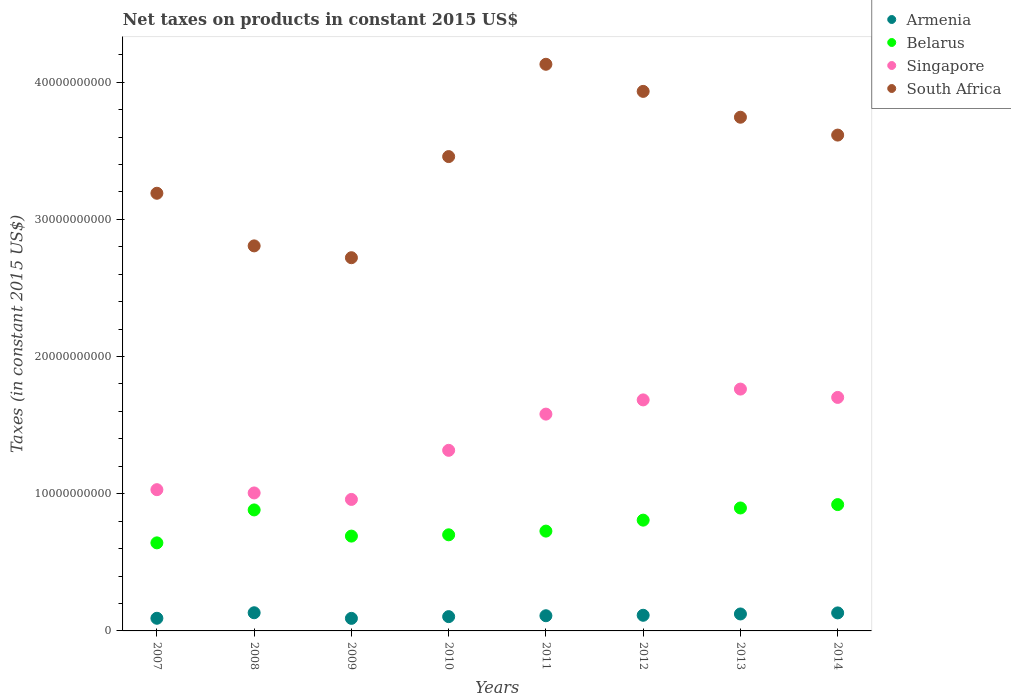How many different coloured dotlines are there?
Your response must be concise. 4. What is the net taxes on products in Belarus in 2011?
Your answer should be compact. 7.28e+09. Across all years, what is the maximum net taxes on products in Belarus?
Your answer should be compact. 9.21e+09. Across all years, what is the minimum net taxes on products in Belarus?
Offer a terse response. 6.42e+09. In which year was the net taxes on products in Armenia maximum?
Make the answer very short. 2008. In which year was the net taxes on products in South Africa minimum?
Your response must be concise. 2009. What is the total net taxes on products in Singapore in the graph?
Offer a very short reply. 1.10e+11. What is the difference between the net taxes on products in Armenia in 2008 and that in 2010?
Offer a very short reply. 2.83e+08. What is the difference between the net taxes on products in Belarus in 2011 and the net taxes on products in Armenia in 2007?
Your answer should be very brief. 6.35e+09. What is the average net taxes on products in Armenia per year?
Provide a succinct answer. 1.13e+09. In the year 2013, what is the difference between the net taxes on products in Belarus and net taxes on products in Armenia?
Provide a succinct answer. 7.73e+09. In how many years, is the net taxes on products in Belarus greater than 30000000000 US$?
Keep it short and to the point. 0. What is the ratio of the net taxes on products in Singapore in 2009 to that in 2011?
Your answer should be very brief. 0.61. Is the net taxes on products in Belarus in 2007 less than that in 2009?
Provide a succinct answer. Yes. Is the difference between the net taxes on products in Belarus in 2010 and 2012 greater than the difference between the net taxes on products in Armenia in 2010 and 2012?
Your answer should be very brief. No. What is the difference between the highest and the second highest net taxes on products in Armenia?
Your response must be concise. 1.13e+07. What is the difference between the highest and the lowest net taxes on products in Belarus?
Provide a succinct answer. 2.79e+09. In how many years, is the net taxes on products in Armenia greater than the average net taxes on products in Armenia taken over all years?
Provide a succinct answer. 4. Is it the case that in every year, the sum of the net taxes on products in South Africa and net taxes on products in Armenia  is greater than the sum of net taxes on products in Belarus and net taxes on products in Singapore?
Make the answer very short. Yes. Is it the case that in every year, the sum of the net taxes on products in Belarus and net taxes on products in Singapore  is greater than the net taxes on products in Armenia?
Your answer should be compact. Yes. Where does the legend appear in the graph?
Keep it short and to the point. Top right. How many legend labels are there?
Offer a very short reply. 4. How are the legend labels stacked?
Provide a succinct answer. Vertical. What is the title of the graph?
Provide a short and direct response. Net taxes on products in constant 2015 US$. What is the label or title of the X-axis?
Offer a terse response. Years. What is the label or title of the Y-axis?
Provide a succinct answer. Taxes (in constant 2015 US$). What is the Taxes (in constant 2015 US$) in Armenia in 2007?
Your answer should be very brief. 9.22e+08. What is the Taxes (in constant 2015 US$) of Belarus in 2007?
Your answer should be compact. 6.42e+09. What is the Taxes (in constant 2015 US$) in Singapore in 2007?
Provide a short and direct response. 1.03e+1. What is the Taxes (in constant 2015 US$) in South Africa in 2007?
Keep it short and to the point. 3.19e+1. What is the Taxes (in constant 2015 US$) in Armenia in 2008?
Ensure brevity in your answer.  1.32e+09. What is the Taxes (in constant 2015 US$) of Belarus in 2008?
Make the answer very short. 8.82e+09. What is the Taxes (in constant 2015 US$) in Singapore in 2008?
Your answer should be compact. 1.01e+1. What is the Taxes (in constant 2015 US$) in South Africa in 2008?
Your answer should be very brief. 2.81e+1. What is the Taxes (in constant 2015 US$) in Armenia in 2009?
Your response must be concise. 9.15e+08. What is the Taxes (in constant 2015 US$) in Belarus in 2009?
Make the answer very short. 6.91e+09. What is the Taxes (in constant 2015 US$) in Singapore in 2009?
Provide a succinct answer. 9.59e+09. What is the Taxes (in constant 2015 US$) of South Africa in 2009?
Your answer should be very brief. 2.72e+1. What is the Taxes (in constant 2015 US$) in Armenia in 2010?
Give a very brief answer. 1.04e+09. What is the Taxes (in constant 2015 US$) in Belarus in 2010?
Keep it short and to the point. 7.01e+09. What is the Taxes (in constant 2015 US$) of Singapore in 2010?
Provide a short and direct response. 1.32e+1. What is the Taxes (in constant 2015 US$) in South Africa in 2010?
Provide a succinct answer. 3.46e+1. What is the Taxes (in constant 2015 US$) in Armenia in 2011?
Provide a succinct answer. 1.11e+09. What is the Taxes (in constant 2015 US$) in Belarus in 2011?
Your response must be concise. 7.28e+09. What is the Taxes (in constant 2015 US$) in Singapore in 2011?
Give a very brief answer. 1.58e+1. What is the Taxes (in constant 2015 US$) of South Africa in 2011?
Provide a succinct answer. 4.13e+1. What is the Taxes (in constant 2015 US$) of Armenia in 2012?
Offer a very short reply. 1.14e+09. What is the Taxes (in constant 2015 US$) in Belarus in 2012?
Offer a terse response. 8.08e+09. What is the Taxes (in constant 2015 US$) of Singapore in 2012?
Make the answer very short. 1.68e+1. What is the Taxes (in constant 2015 US$) of South Africa in 2012?
Provide a succinct answer. 3.93e+1. What is the Taxes (in constant 2015 US$) in Armenia in 2013?
Ensure brevity in your answer.  1.24e+09. What is the Taxes (in constant 2015 US$) in Belarus in 2013?
Your answer should be very brief. 8.96e+09. What is the Taxes (in constant 2015 US$) of Singapore in 2013?
Your response must be concise. 1.76e+1. What is the Taxes (in constant 2015 US$) of South Africa in 2013?
Your response must be concise. 3.74e+1. What is the Taxes (in constant 2015 US$) in Armenia in 2014?
Offer a very short reply. 1.31e+09. What is the Taxes (in constant 2015 US$) in Belarus in 2014?
Offer a terse response. 9.21e+09. What is the Taxes (in constant 2015 US$) of Singapore in 2014?
Provide a succinct answer. 1.70e+1. What is the Taxes (in constant 2015 US$) in South Africa in 2014?
Your answer should be compact. 3.61e+1. Across all years, what is the maximum Taxes (in constant 2015 US$) in Armenia?
Your answer should be very brief. 1.32e+09. Across all years, what is the maximum Taxes (in constant 2015 US$) of Belarus?
Ensure brevity in your answer.  9.21e+09. Across all years, what is the maximum Taxes (in constant 2015 US$) of Singapore?
Offer a terse response. 1.76e+1. Across all years, what is the maximum Taxes (in constant 2015 US$) of South Africa?
Offer a very short reply. 4.13e+1. Across all years, what is the minimum Taxes (in constant 2015 US$) in Armenia?
Your answer should be very brief. 9.15e+08. Across all years, what is the minimum Taxes (in constant 2015 US$) in Belarus?
Ensure brevity in your answer.  6.42e+09. Across all years, what is the minimum Taxes (in constant 2015 US$) of Singapore?
Offer a terse response. 9.59e+09. Across all years, what is the minimum Taxes (in constant 2015 US$) in South Africa?
Offer a very short reply. 2.72e+1. What is the total Taxes (in constant 2015 US$) in Armenia in the graph?
Provide a succinct answer. 9.00e+09. What is the total Taxes (in constant 2015 US$) in Belarus in the graph?
Your response must be concise. 6.27e+1. What is the total Taxes (in constant 2015 US$) of Singapore in the graph?
Give a very brief answer. 1.10e+11. What is the total Taxes (in constant 2015 US$) of South Africa in the graph?
Ensure brevity in your answer.  2.76e+11. What is the difference between the Taxes (in constant 2015 US$) in Armenia in 2007 and that in 2008?
Your answer should be compact. -4.02e+08. What is the difference between the Taxes (in constant 2015 US$) of Belarus in 2007 and that in 2008?
Make the answer very short. -2.40e+09. What is the difference between the Taxes (in constant 2015 US$) in Singapore in 2007 and that in 2008?
Offer a very short reply. 2.39e+08. What is the difference between the Taxes (in constant 2015 US$) of South Africa in 2007 and that in 2008?
Offer a very short reply. 3.84e+09. What is the difference between the Taxes (in constant 2015 US$) of Armenia in 2007 and that in 2009?
Your answer should be compact. 7.03e+06. What is the difference between the Taxes (in constant 2015 US$) in Belarus in 2007 and that in 2009?
Provide a short and direct response. -4.92e+08. What is the difference between the Taxes (in constant 2015 US$) of Singapore in 2007 and that in 2009?
Offer a very short reply. 7.11e+08. What is the difference between the Taxes (in constant 2015 US$) in South Africa in 2007 and that in 2009?
Offer a terse response. 4.70e+09. What is the difference between the Taxes (in constant 2015 US$) of Armenia in 2007 and that in 2010?
Your answer should be very brief. -1.19e+08. What is the difference between the Taxes (in constant 2015 US$) in Belarus in 2007 and that in 2010?
Provide a short and direct response. -5.87e+08. What is the difference between the Taxes (in constant 2015 US$) of Singapore in 2007 and that in 2010?
Your response must be concise. -2.87e+09. What is the difference between the Taxes (in constant 2015 US$) in South Africa in 2007 and that in 2010?
Make the answer very short. -2.67e+09. What is the difference between the Taxes (in constant 2015 US$) of Armenia in 2007 and that in 2011?
Keep it short and to the point. -1.84e+08. What is the difference between the Taxes (in constant 2015 US$) in Belarus in 2007 and that in 2011?
Give a very brief answer. -8.57e+08. What is the difference between the Taxes (in constant 2015 US$) in Singapore in 2007 and that in 2011?
Your answer should be very brief. -5.51e+09. What is the difference between the Taxes (in constant 2015 US$) of South Africa in 2007 and that in 2011?
Provide a short and direct response. -9.40e+09. What is the difference between the Taxes (in constant 2015 US$) of Armenia in 2007 and that in 2012?
Offer a terse response. -2.18e+08. What is the difference between the Taxes (in constant 2015 US$) in Belarus in 2007 and that in 2012?
Offer a very short reply. -1.66e+09. What is the difference between the Taxes (in constant 2015 US$) of Singapore in 2007 and that in 2012?
Your response must be concise. -6.54e+09. What is the difference between the Taxes (in constant 2015 US$) of South Africa in 2007 and that in 2012?
Make the answer very short. -7.43e+09. What is the difference between the Taxes (in constant 2015 US$) in Armenia in 2007 and that in 2013?
Keep it short and to the point. -3.14e+08. What is the difference between the Taxes (in constant 2015 US$) in Belarus in 2007 and that in 2013?
Offer a very short reply. -2.54e+09. What is the difference between the Taxes (in constant 2015 US$) in Singapore in 2007 and that in 2013?
Give a very brief answer. -7.33e+09. What is the difference between the Taxes (in constant 2015 US$) of South Africa in 2007 and that in 2013?
Make the answer very short. -5.54e+09. What is the difference between the Taxes (in constant 2015 US$) in Armenia in 2007 and that in 2014?
Provide a succinct answer. -3.91e+08. What is the difference between the Taxes (in constant 2015 US$) of Belarus in 2007 and that in 2014?
Offer a very short reply. -2.79e+09. What is the difference between the Taxes (in constant 2015 US$) in Singapore in 2007 and that in 2014?
Ensure brevity in your answer.  -6.73e+09. What is the difference between the Taxes (in constant 2015 US$) of South Africa in 2007 and that in 2014?
Your answer should be very brief. -4.24e+09. What is the difference between the Taxes (in constant 2015 US$) in Armenia in 2008 and that in 2009?
Offer a terse response. 4.09e+08. What is the difference between the Taxes (in constant 2015 US$) in Belarus in 2008 and that in 2009?
Your answer should be compact. 1.91e+09. What is the difference between the Taxes (in constant 2015 US$) of Singapore in 2008 and that in 2009?
Offer a very short reply. 4.73e+08. What is the difference between the Taxes (in constant 2015 US$) in South Africa in 2008 and that in 2009?
Your answer should be compact. 8.62e+08. What is the difference between the Taxes (in constant 2015 US$) in Armenia in 2008 and that in 2010?
Offer a terse response. 2.83e+08. What is the difference between the Taxes (in constant 2015 US$) of Belarus in 2008 and that in 2010?
Your answer should be compact. 1.81e+09. What is the difference between the Taxes (in constant 2015 US$) in Singapore in 2008 and that in 2010?
Ensure brevity in your answer.  -3.11e+09. What is the difference between the Taxes (in constant 2015 US$) in South Africa in 2008 and that in 2010?
Your response must be concise. -6.51e+09. What is the difference between the Taxes (in constant 2015 US$) in Armenia in 2008 and that in 2011?
Offer a very short reply. 2.18e+08. What is the difference between the Taxes (in constant 2015 US$) of Belarus in 2008 and that in 2011?
Your response must be concise. 1.54e+09. What is the difference between the Taxes (in constant 2015 US$) of Singapore in 2008 and that in 2011?
Keep it short and to the point. -5.75e+09. What is the difference between the Taxes (in constant 2015 US$) in South Africa in 2008 and that in 2011?
Ensure brevity in your answer.  -1.32e+1. What is the difference between the Taxes (in constant 2015 US$) of Armenia in 2008 and that in 2012?
Provide a short and direct response. 1.84e+08. What is the difference between the Taxes (in constant 2015 US$) in Belarus in 2008 and that in 2012?
Give a very brief answer. 7.45e+08. What is the difference between the Taxes (in constant 2015 US$) in Singapore in 2008 and that in 2012?
Your answer should be compact. -6.78e+09. What is the difference between the Taxes (in constant 2015 US$) of South Africa in 2008 and that in 2012?
Provide a succinct answer. -1.13e+1. What is the difference between the Taxes (in constant 2015 US$) of Armenia in 2008 and that in 2013?
Offer a terse response. 8.83e+07. What is the difference between the Taxes (in constant 2015 US$) in Belarus in 2008 and that in 2013?
Your answer should be compact. -1.42e+08. What is the difference between the Taxes (in constant 2015 US$) of Singapore in 2008 and that in 2013?
Your answer should be very brief. -7.57e+09. What is the difference between the Taxes (in constant 2015 US$) of South Africa in 2008 and that in 2013?
Your answer should be very brief. -9.38e+09. What is the difference between the Taxes (in constant 2015 US$) of Armenia in 2008 and that in 2014?
Offer a very short reply. 1.13e+07. What is the difference between the Taxes (in constant 2015 US$) in Belarus in 2008 and that in 2014?
Keep it short and to the point. -3.89e+08. What is the difference between the Taxes (in constant 2015 US$) of Singapore in 2008 and that in 2014?
Your answer should be very brief. -6.96e+09. What is the difference between the Taxes (in constant 2015 US$) in South Africa in 2008 and that in 2014?
Provide a short and direct response. -8.08e+09. What is the difference between the Taxes (in constant 2015 US$) in Armenia in 2009 and that in 2010?
Your response must be concise. -1.26e+08. What is the difference between the Taxes (in constant 2015 US$) of Belarus in 2009 and that in 2010?
Your answer should be compact. -9.48e+07. What is the difference between the Taxes (in constant 2015 US$) of Singapore in 2009 and that in 2010?
Your response must be concise. -3.58e+09. What is the difference between the Taxes (in constant 2015 US$) of South Africa in 2009 and that in 2010?
Provide a succinct answer. -7.37e+09. What is the difference between the Taxes (in constant 2015 US$) of Armenia in 2009 and that in 2011?
Give a very brief answer. -1.91e+08. What is the difference between the Taxes (in constant 2015 US$) of Belarus in 2009 and that in 2011?
Ensure brevity in your answer.  -3.64e+08. What is the difference between the Taxes (in constant 2015 US$) in Singapore in 2009 and that in 2011?
Your response must be concise. -6.22e+09. What is the difference between the Taxes (in constant 2015 US$) of South Africa in 2009 and that in 2011?
Provide a succinct answer. -1.41e+1. What is the difference between the Taxes (in constant 2015 US$) in Armenia in 2009 and that in 2012?
Keep it short and to the point. -2.25e+08. What is the difference between the Taxes (in constant 2015 US$) of Belarus in 2009 and that in 2012?
Offer a very short reply. -1.16e+09. What is the difference between the Taxes (in constant 2015 US$) of Singapore in 2009 and that in 2012?
Offer a very short reply. -7.26e+09. What is the difference between the Taxes (in constant 2015 US$) of South Africa in 2009 and that in 2012?
Offer a terse response. -1.21e+1. What is the difference between the Taxes (in constant 2015 US$) in Armenia in 2009 and that in 2013?
Your response must be concise. -3.21e+08. What is the difference between the Taxes (in constant 2015 US$) of Belarus in 2009 and that in 2013?
Your answer should be compact. -2.05e+09. What is the difference between the Taxes (in constant 2015 US$) in Singapore in 2009 and that in 2013?
Offer a very short reply. -8.04e+09. What is the difference between the Taxes (in constant 2015 US$) in South Africa in 2009 and that in 2013?
Offer a very short reply. -1.02e+1. What is the difference between the Taxes (in constant 2015 US$) of Armenia in 2009 and that in 2014?
Ensure brevity in your answer.  -3.98e+08. What is the difference between the Taxes (in constant 2015 US$) in Belarus in 2009 and that in 2014?
Keep it short and to the point. -2.30e+09. What is the difference between the Taxes (in constant 2015 US$) of Singapore in 2009 and that in 2014?
Give a very brief answer. -7.44e+09. What is the difference between the Taxes (in constant 2015 US$) in South Africa in 2009 and that in 2014?
Your answer should be very brief. -8.94e+09. What is the difference between the Taxes (in constant 2015 US$) in Armenia in 2010 and that in 2011?
Keep it short and to the point. -6.55e+07. What is the difference between the Taxes (in constant 2015 US$) in Belarus in 2010 and that in 2011?
Keep it short and to the point. -2.70e+08. What is the difference between the Taxes (in constant 2015 US$) of Singapore in 2010 and that in 2011?
Your answer should be very brief. -2.64e+09. What is the difference between the Taxes (in constant 2015 US$) in South Africa in 2010 and that in 2011?
Give a very brief answer. -6.73e+09. What is the difference between the Taxes (in constant 2015 US$) of Armenia in 2010 and that in 2012?
Give a very brief answer. -9.92e+07. What is the difference between the Taxes (in constant 2015 US$) in Belarus in 2010 and that in 2012?
Your answer should be very brief. -1.07e+09. What is the difference between the Taxes (in constant 2015 US$) in Singapore in 2010 and that in 2012?
Ensure brevity in your answer.  -3.68e+09. What is the difference between the Taxes (in constant 2015 US$) in South Africa in 2010 and that in 2012?
Make the answer very short. -4.75e+09. What is the difference between the Taxes (in constant 2015 US$) of Armenia in 2010 and that in 2013?
Provide a short and direct response. -1.95e+08. What is the difference between the Taxes (in constant 2015 US$) in Belarus in 2010 and that in 2013?
Provide a succinct answer. -1.96e+09. What is the difference between the Taxes (in constant 2015 US$) of Singapore in 2010 and that in 2013?
Make the answer very short. -4.46e+09. What is the difference between the Taxes (in constant 2015 US$) in South Africa in 2010 and that in 2013?
Your response must be concise. -2.87e+09. What is the difference between the Taxes (in constant 2015 US$) of Armenia in 2010 and that in 2014?
Your answer should be compact. -2.72e+08. What is the difference between the Taxes (in constant 2015 US$) in Belarus in 2010 and that in 2014?
Offer a terse response. -2.20e+09. What is the difference between the Taxes (in constant 2015 US$) in Singapore in 2010 and that in 2014?
Your answer should be very brief. -3.86e+09. What is the difference between the Taxes (in constant 2015 US$) of South Africa in 2010 and that in 2014?
Give a very brief answer. -1.57e+09. What is the difference between the Taxes (in constant 2015 US$) in Armenia in 2011 and that in 2012?
Your answer should be compact. -3.36e+07. What is the difference between the Taxes (in constant 2015 US$) in Belarus in 2011 and that in 2012?
Your answer should be compact. -7.99e+08. What is the difference between the Taxes (in constant 2015 US$) in Singapore in 2011 and that in 2012?
Provide a short and direct response. -1.04e+09. What is the difference between the Taxes (in constant 2015 US$) of South Africa in 2011 and that in 2012?
Your response must be concise. 1.98e+09. What is the difference between the Taxes (in constant 2015 US$) in Armenia in 2011 and that in 2013?
Give a very brief answer. -1.29e+08. What is the difference between the Taxes (in constant 2015 US$) of Belarus in 2011 and that in 2013?
Make the answer very short. -1.69e+09. What is the difference between the Taxes (in constant 2015 US$) of Singapore in 2011 and that in 2013?
Ensure brevity in your answer.  -1.82e+09. What is the difference between the Taxes (in constant 2015 US$) of South Africa in 2011 and that in 2013?
Provide a succinct answer. 3.86e+09. What is the difference between the Taxes (in constant 2015 US$) in Armenia in 2011 and that in 2014?
Provide a short and direct response. -2.06e+08. What is the difference between the Taxes (in constant 2015 US$) in Belarus in 2011 and that in 2014?
Your answer should be very brief. -1.93e+09. What is the difference between the Taxes (in constant 2015 US$) in Singapore in 2011 and that in 2014?
Keep it short and to the point. -1.22e+09. What is the difference between the Taxes (in constant 2015 US$) of South Africa in 2011 and that in 2014?
Keep it short and to the point. 5.16e+09. What is the difference between the Taxes (in constant 2015 US$) of Armenia in 2012 and that in 2013?
Offer a terse response. -9.58e+07. What is the difference between the Taxes (in constant 2015 US$) in Belarus in 2012 and that in 2013?
Ensure brevity in your answer.  -8.86e+08. What is the difference between the Taxes (in constant 2015 US$) in Singapore in 2012 and that in 2013?
Your response must be concise. -7.88e+08. What is the difference between the Taxes (in constant 2015 US$) of South Africa in 2012 and that in 2013?
Give a very brief answer. 1.88e+09. What is the difference between the Taxes (in constant 2015 US$) in Armenia in 2012 and that in 2014?
Your answer should be compact. -1.73e+08. What is the difference between the Taxes (in constant 2015 US$) in Belarus in 2012 and that in 2014?
Ensure brevity in your answer.  -1.13e+09. What is the difference between the Taxes (in constant 2015 US$) of Singapore in 2012 and that in 2014?
Make the answer very short. -1.81e+08. What is the difference between the Taxes (in constant 2015 US$) in South Africa in 2012 and that in 2014?
Keep it short and to the point. 3.19e+09. What is the difference between the Taxes (in constant 2015 US$) in Armenia in 2013 and that in 2014?
Keep it short and to the point. -7.70e+07. What is the difference between the Taxes (in constant 2015 US$) in Belarus in 2013 and that in 2014?
Offer a terse response. -2.47e+08. What is the difference between the Taxes (in constant 2015 US$) in Singapore in 2013 and that in 2014?
Provide a short and direct response. 6.07e+08. What is the difference between the Taxes (in constant 2015 US$) in South Africa in 2013 and that in 2014?
Provide a short and direct response. 1.30e+09. What is the difference between the Taxes (in constant 2015 US$) in Armenia in 2007 and the Taxes (in constant 2015 US$) in Belarus in 2008?
Make the answer very short. -7.90e+09. What is the difference between the Taxes (in constant 2015 US$) of Armenia in 2007 and the Taxes (in constant 2015 US$) of Singapore in 2008?
Your answer should be very brief. -9.14e+09. What is the difference between the Taxes (in constant 2015 US$) in Armenia in 2007 and the Taxes (in constant 2015 US$) in South Africa in 2008?
Give a very brief answer. -2.71e+1. What is the difference between the Taxes (in constant 2015 US$) in Belarus in 2007 and the Taxes (in constant 2015 US$) in Singapore in 2008?
Ensure brevity in your answer.  -3.64e+09. What is the difference between the Taxes (in constant 2015 US$) of Belarus in 2007 and the Taxes (in constant 2015 US$) of South Africa in 2008?
Give a very brief answer. -2.16e+1. What is the difference between the Taxes (in constant 2015 US$) of Singapore in 2007 and the Taxes (in constant 2015 US$) of South Africa in 2008?
Make the answer very short. -1.78e+1. What is the difference between the Taxes (in constant 2015 US$) in Armenia in 2007 and the Taxes (in constant 2015 US$) in Belarus in 2009?
Give a very brief answer. -5.99e+09. What is the difference between the Taxes (in constant 2015 US$) in Armenia in 2007 and the Taxes (in constant 2015 US$) in Singapore in 2009?
Make the answer very short. -8.66e+09. What is the difference between the Taxes (in constant 2015 US$) in Armenia in 2007 and the Taxes (in constant 2015 US$) in South Africa in 2009?
Provide a short and direct response. -2.63e+1. What is the difference between the Taxes (in constant 2015 US$) in Belarus in 2007 and the Taxes (in constant 2015 US$) in Singapore in 2009?
Make the answer very short. -3.17e+09. What is the difference between the Taxes (in constant 2015 US$) of Belarus in 2007 and the Taxes (in constant 2015 US$) of South Africa in 2009?
Offer a very short reply. -2.08e+1. What is the difference between the Taxes (in constant 2015 US$) of Singapore in 2007 and the Taxes (in constant 2015 US$) of South Africa in 2009?
Keep it short and to the point. -1.69e+1. What is the difference between the Taxes (in constant 2015 US$) in Armenia in 2007 and the Taxes (in constant 2015 US$) in Belarus in 2010?
Provide a succinct answer. -6.08e+09. What is the difference between the Taxes (in constant 2015 US$) in Armenia in 2007 and the Taxes (in constant 2015 US$) in Singapore in 2010?
Provide a short and direct response. -1.22e+1. What is the difference between the Taxes (in constant 2015 US$) of Armenia in 2007 and the Taxes (in constant 2015 US$) of South Africa in 2010?
Keep it short and to the point. -3.37e+1. What is the difference between the Taxes (in constant 2015 US$) of Belarus in 2007 and the Taxes (in constant 2015 US$) of Singapore in 2010?
Keep it short and to the point. -6.75e+09. What is the difference between the Taxes (in constant 2015 US$) of Belarus in 2007 and the Taxes (in constant 2015 US$) of South Africa in 2010?
Offer a very short reply. -2.82e+1. What is the difference between the Taxes (in constant 2015 US$) in Singapore in 2007 and the Taxes (in constant 2015 US$) in South Africa in 2010?
Your answer should be very brief. -2.43e+1. What is the difference between the Taxes (in constant 2015 US$) in Armenia in 2007 and the Taxes (in constant 2015 US$) in Belarus in 2011?
Offer a terse response. -6.35e+09. What is the difference between the Taxes (in constant 2015 US$) of Armenia in 2007 and the Taxes (in constant 2015 US$) of Singapore in 2011?
Your answer should be compact. -1.49e+1. What is the difference between the Taxes (in constant 2015 US$) in Armenia in 2007 and the Taxes (in constant 2015 US$) in South Africa in 2011?
Your response must be concise. -4.04e+1. What is the difference between the Taxes (in constant 2015 US$) in Belarus in 2007 and the Taxes (in constant 2015 US$) in Singapore in 2011?
Ensure brevity in your answer.  -9.39e+09. What is the difference between the Taxes (in constant 2015 US$) of Belarus in 2007 and the Taxes (in constant 2015 US$) of South Africa in 2011?
Offer a terse response. -3.49e+1. What is the difference between the Taxes (in constant 2015 US$) of Singapore in 2007 and the Taxes (in constant 2015 US$) of South Africa in 2011?
Provide a short and direct response. -3.10e+1. What is the difference between the Taxes (in constant 2015 US$) of Armenia in 2007 and the Taxes (in constant 2015 US$) of Belarus in 2012?
Your answer should be very brief. -7.15e+09. What is the difference between the Taxes (in constant 2015 US$) in Armenia in 2007 and the Taxes (in constant 2015 US$) in Singapore in 2012?
Keep it short and to the point. -1.59e+1. What is the difference between the Taxes (in constant 2015 US$) in Armenia in 2007 and the Taxes (in constant 2015 US$) in South Africa in 2012?
Your answer should be very brief. -3.84e+1. What is the difference between the Taxes (in constant 2015 US$) of Belarus in 2007 and the Taxes (in constant 2015 US$) of Singapore in 2012?
Offer a very short reply. -1.04e+1. What is the difference between the Taxes (in constant 2015 US$) of Belarus in 2007 and the Taxes (in constant 2015 US$) of South Africa in 2012?
Your response must be concise. -3.29e+1. What is the difference between the Taxes (in constant 2015 US$) of Singapore in 2007 and the Taxes (in constant 2015 US$) of South Africa in 2012?
Your answer should be compact. -2.90e+1. What is the difference between the Taxes (in constant 2015 US$) in Armenia in 2007 and the Taxes (in constant 2015 US$) in Belarus in 2013?
Make the answer very short. -8.04e+09. What is the difference between the Taxes (in constant 2015 US$) of Armenia in 2007 and the Taxes (in constant 2015 US$) of Singapore in 2013?
Provide a short and direct response. -1.67e+1. What is the difference between the Taxes (in constant 2015 US$) of Armenia in 2007 and the Taxes (in constant 2015 US$) of South Africa in 2013?
Ensure brevity in your answer.  -3.65e+1. What is the difference between the Taxes (in constant 2015 US$) in Belarus in 2007 and the Taxes (in constant 2015 US$) in Singapore in 2013?
Your response must be concise. -1.12e+1. What is the difference between the Taxes (in constant 2015 US$) in Belarus in 2007 and the Taxes (in constant 2015 US$) in South Africa in 2013?
Make the answer very short. -3.10e+1. What is the difference between the Taxes (in constant 2015 US$) of Singapore in 2007 and the Taxes (in constant 2015 US$) of South Africa in 2013?
Ensure brevity in your answer.  -2.71e+1. What is the difference between the Taxes (in constant 2015 US$) in Armenia in 2007 and the Taxes (in constant 2015 US$) in Belarus in 2014?
Keep it short and to the point. -8.29e+09. What is the difference between the Taxes (in constant 2015 US$) of Armenia in 2007 and the Taxes (in constant 2015 US$) of Singapore in 2014?
Provide a succinct answer. -1.61e+1. What is the difference between the Taxes (in constant 2015 US$) in Armenia in 2007 and the Taxes (in constant 2015 US$) in South Africa in 2014?
Your answer should be very brief. -3.52e+1. What is the difference between the Taxes (in constant 2015 US$) of Belarus in 2007 and the Taxes (in constant 2015 US$) of Singapore in 2014?
Provide a succinct answer. -1.06e+1. What is the difference between the Taxes (in constant 2015 US$) of Belarus in 2007 and the Taxes (in constant 2015 US$) of South Africa in 2014?
Provide a short and direct response. -2.97e+1. What is the difference between the Taxes (in constant 2015 US$) of Singapore in 2007 and the Taxes (in constant 2015 US$) of South Africa in 2014?
Ensure brevity in your answer.  -2.58e+1. What is the difference between the Taxes (in constant 2015 US$) in Armenia in 2008 and the Taxes (in constant 2015 US$) in Belarus in 2009?
Make the answer very short. -5.59e+09. What is the difference between the Taxes (in constant 2015 US$) in Armenia in 2008 and the Taxes (in constant 2015 US$) in Singapore in 2009?
Your answer should be very brief. -8.26e+09. What is the difference between the Taxes (in constant 2015 US$) of Armenia in 2008 and the Taxes (in constant 2015 US$) of South Africa in 2009?
Your response must be concise. -2.59e+1. What is the difference between the Taxes (in constant 2015 US$) in Belarus in 2008 and the Taxes (in constant 2015 US$) in Singapore in 2009?
Give a very brief answer. -7.65e+08. What is the difference between the Taxes (in constant 2015 US$) of Belarus in 2008 and the Taxes (in constant 2015 US$) of South Africa in 2009?
Offer a very short reply. -1.84e+1. What is the difference between the Taxes (in constant 2015 US$) of Singapore in 2008 and the Taxes (in constant 2015 US$) of South Africa in 2009?
Provide a short and direct response. -1.71e+1. What is the difference between the Taxes (in constant 2015 US$) of Armenia in 2008 and the Taxes (in constant 2015 US$) of Belarus in 2010?
Give a very brief answer. -5.68e+09. What is the difference between the Taxes (in constant 2015 US$) in Armenia in 2008 and the Taxes (in constant 2015 US$) in Singapore in 2010?
Offer a very short reply. -1.18e+1. What is the difference between the Taxes (in constant 2015 US$) of Armenia in 2008 and the Taxes (in constant 2015 US$) of South Africa in 2010?
Make the answer very short. -3.33e+1. What is the difference between the Taxes (in constant 2015 US$) in Belarus in 2008 and the Taxes (in constant 2015 US$) in Singapore in 2010?
Offer a very short reply. -4.34e+09. What is the difference between the Taxes (in constant 2015 US$) in Belarus in 2008 and the Taxes (in constant 2015 US$) in South Africa in 2010?
Your answer should be very brief. -2.58e+1. What is the difference between the Taxes (in constant 2015 US$) in Singapore in 2008 and the Taxes (in constant 2015 US$) in South Africa in 2010?
Provide a succinct answer. -2.45e+1. What is the difference between the Taxes (in constant 2015 US$) in Armenia in 2008 and the Taxes (in constant 2015 US$) in Belarus in 2011?
Ensure brevity in your answer.  -5.95e+09. What is the difference between the Taxes (in constant 2015 US$) in Armenia in 2008 and the Taxes (in constant 2015 US$) in Singapore in 2011?
Give a very brief answer. -1.45e+1. What is the difference between the Taxes (in constant 2015 US$) of Armenia in 2008 and the Taxes (in constant 2015 US$) of South Africa in 2011?
Make the answer very short. -4.00e+1. What is the difference between the Taxes (in constant 2015 US$) in Belarus in 2008 and the Taxes (in constant 2015 US$) in Singapore in 2011?
Ensure brevity in your answer.  -6.98e+09. What is the difference between the Taxes (in constant 2015 US$) in Belarus in 2008 and the Taxes (in constant 2015 US$) in South Africa in 2011?
Provide a short and direct response. -3.25e+1. What is the difference between the Taxes (in constant 2015 US$) of Singapore in 2008 and the Taxes (in constant 2015 US$) of South Africa in 2011?
Offer a very short reply. -3.12e+1. What is the difference between the Taxes (in constant 2015 US$) of Armenia in 2008 and the Taxes (in constant 2015 US$) of Belarus in 2012?
Give a very brief answer. -6.75e+09. What is the difference between the Taxes (in constant 2015 US$) in Armenia in 2008 and the Taxes (in constant 2015 US$) in Singapore in 2012?
Ensure brevity in your answer.  -1.55e+1. What is the difference between the Taxes (in constant 2015 US$) of Armenia in 2008 and the Taxes (in constant 2015 US$) of South Africa in 2012?
Your answer should be compact. -3.80e+1. What is the difference between the Taxes (in constant 2015 US$) in Belarus in 2008 and the Taxes (in constant 2015 US$) in Singapore in 2012?
Ensure brevity in your answer.  -8.02e+09. What is the difference between the Taxes (in constant 2015 US$) of Belarus in 2008 and the Taxes (in constant 2015 US$) of South Africa in 2012?
Keep it short and to the point. -3.05e+1. What is the difference between the Taxes (in constant 2015 US$) of Singapore in 2008 and the Taxes (in constant 2015 US$) of South Africa in 2012?
Keep it short and to the point. -2.93e+1. What is the difference between the Taxes (in constant 2015 US$) of Armenia in 2008 and the Taxes (in constant 2015 US$) of Belarus in 2013?
Your answer should be compact. -7.64e+09. What is the difference between the Taxes (in constant 2015 US$) in Armenia in 2008 and the Taxes (in constant 2015 US$) in Singapore in 2013?
Offer a very short reply. -1.63e+1. What is the difference between the Taxes (in constant 2015 US$) in Armenia in 2008 and the Taxes (in constant 2015 US$) in South Africa in 2013?
Ensure brevity in your answer.  -3.61e+1. What is the difference between the Taxes (in constant 2015 US$) of Belarus in 2008 and the Taxes (in constant 2015 US$) of Singapore in 2013?
Ensure brevity in your answer.  -8.81e+09. What is the difference between the Taxes (in constant 2015 US$) of Belarus in 2008 and the Taxes (in constant 2015 US$) of South Africa in 2013?
Give a very brief answer. -2.86e+1. What is the difference between the Taxes (in constant 2015 US$) of Singapore in 2008 and the Taxes (in constant 2015 US$) of South Africa in 2013?
Your answer should be compact. -2.74e+1. What is the difference between the Taxes (in constant 2015 US$) of Armenia in 2008 and the Taxes (in constant 2015 US$) of Belarus in 2014?
Your answer should be compact. -7.88e+09. What is the difference between the Taxes (in constant 2015 US$) of Armenia in 2008 and the Taxes (in constant 2015 US$) of Singapore in 2014?
Provide a short and direct response. -1.57e+1. What is the difference between the Taxes (in constant 2015 US$) in Armenia in 2008 and the Taxes (in constant 2015 US$) in South Africa in 2014?
Offer a terse response. -3.48e+1. What is the difference between the Taxes (in constant 2015 US$) in Belarus in 2008 and the Taxes (in constant 2015 US$) in Singapore in 2014?
Provide a succinct answer. -8.20e+09. What is the difference between the Taxes (in constant 2015 US$) of Belarus in 2008 and the Taxes (in constant 2015 US$) of South Africa in 2014?
Your response must be concise. -2.73e+1. What is the difference between the Taxes (in constant 2015 US$) of Singapore in 2008 and the Taxes (in constant 2015 US$) of South Africa in 2014?
Your answer should be very brief. -2.61e+1. What is the difference between the Taxes (in constant 2015 US$) in Armenia in 2009 and the Taxes (in constant 2015 US$) in Belarus in 2010?
Your answer should be compact. -6.09e+09. What is the difference between the Taxes (in constant 2015 US$) in Armenia in 2009 and the Taxes (in constant 2015 US$) in Singapore in 2010?
Keep it short and to the point. -1.22e+1. What is the difference between the Taxes (in constant 2015 US$) in Armenia in 2009 and the Taxes (in constant 2015 US$) in South Africa in 2010?
Your answer should be very brief. -3.37e+1. What is the difference between the Taxes (in constant 2015 US$) of Belarus in 2009 and the Taxes (in constant 2015 US$) of Singapore in 2010?
Offer a terse response. -6.25e+09. What is the difference between the Taxes (in constant 2015 US$) of Belarus in 2009 and the Taxes (in constant 2015 US$) of South Africa in 2010?
Provide a short and direct response. -2.77e+1. What is the difference between the Taxes (in constant 2015 US$) in Singapore in 2009 and the Taxes (in constant 2015 US$) in South Africa in 2010?
Keep it short and to the point. -2.50e+1. What is the difference between the Taxes (in constant 2015 US$) in Armenia in 2009 and the Taxes (in constant 2015 US$) in Belarus in 2011?
Give a very brief answer. -6.36e+09. What is the difference between the Taxes (in constant 2015 US$) of Armenia in 2009 and the Taxes (in constant 2015 US$) of Singapore in 2011?
Give a very brief answer. -1.49e+1. What is the difference between the Taxes (in constant 2015 US$) in Armenia in 2009 and the Taxes (in constant 2015 US$) in South Africa in 2011?
Make the answer very short. -4.04e+1. What is the difference between the Taxes (in constant 2015 US$) of Belarus in 2009 and the Taxes (in constant 2015 US$) of Singapore in 2011?
Keep it short and to the point. -8.89e+09. What is the difference between the Taxes (in constant 2015 US$) of Belarus in 2009 and the Taxes (in constant 2015 US$) of South Africa in 2011?
Offer a very short reply. -3.44e+1. What is the difference between the Taxes (in constant 2015 US$) in Singapore in 2009 and the Taxes (in constant 2015 US$) in South Africa in 2011?
Provide a succinct answer. -3.17e+1. What is the difference between the Taxes (in constant 2015 US$) in Armenia in 2009 and the Taxes (in constant 2015 US$) in Belarus in 2012?
Provide a succinct answer. -7.16e+09. What is the difference between the Taxes (in constant 2015 US$) of Armenia in 2009 and the Taxes (in constant 2015 US$) of Singapore in 2012?
Offer a very short reply. -1.59e+1. What is the difference between the Taxes (in constant 2015 US$) in Armenia in 2009 and the Taxes (in constant 2015 US$) in South Africa in 2012?
Offer a very short reply. -3.84e+1. What is the difference between the Taxes (in constant 2015 US$) of Belarus in 2009 and the Taxes (in constant 2015 US$) of Singapore in 2012?
Offer a terse response. -9.93e+09. What is the difference between the Taxes (in constant 2015 US$) of Belarus in 2009 and the Taxes (in constant 2015 US$) of South Africa in 2012?
Ensure brevity in your answer.  -3.24e+1. What is the difference between the Taxes (in constant 2015 US$) in Singapore in 2009 and the Taxes (in constant 2015 US$) in South Africa in 2012?
Your response must be concise. -2.97e+1. What is the difference between the Taxes (in constant 2015 US$) of Armenia in 2009 and the Taxes (in constant 2015 US$) of Belarus in 2013?
Offer a very short reply. -8.05e+09. What is the difference between the Taxes (in constant 2015 US$) of Armenia in 2009 and the Taxes (in constant 2015 US$) of Singapore in 2013?
Provide a short and direct response. -1.67e+1. What is the difference between the Taxes (in constant 2015 US$) in Armenia in 2009 and the Taxes (in constant 2015 US$) in South Africa in 2013?
Provide a succinct answer. -3.65e+1. What is the difference between the Taxes (in constant 2015 US$) in Belarus in 2009 and the Taxes (in constant 2015 US$) in Singapore in 2013?
Give a very brief answer. -1.07e+1. What is the difference between the Taxes (in constant 2015 US$) in Belarus in 2009 and the Taxes (in constant 2015 US$) in South Africa in 2013?
Ensure brevity in your answer.  -3.05e+1. What is the difference between the Taxes (in constant 2015 US$) in Singapore in 2009 and the Taxes (in constant 2015 US$) in South Africa in 2013?
Your response must be concise. -2.79e+1. What is the difference between the Taxes (in constant 2015 US$) of Armenia in 2009 and the Taxes (in constant 2015 US$) of Belarus in 2014?
Provide a succinct answer. -8.29e+09. What is the difference between the Taxes (in constant 2015 US$) in Armenia in 2009 and the Taxes (in constant 2015 US$) in Singapore in 2014?
Keep it short and to the point. -1.61e+1. What is the difference between the Taxes (in constant 2015 US$) of Armenia in 2009 and the Taxes (in constant 2015 US$) of South Africa in 2014?
Your answer should be compact. -3.52e+1. What is the difference between the Taxes (in constant 2015 US$) of Belarus in 2009 and the Taxes (in constant 2015 US$) of Singapore in 2014?
Your answer should be compact. -1.01e+1. What is the difference between the Taxes (in constant 2015 US$) of Belarus in 2009 and the Taxes (in constant 2015 US$) of South Africa in 2014?
Give a very brief answer. -2.92e+1. What is the difference between the Taxes (in constant 2015 US$) of Singapore in 2009 and the Taxes (in constant 2015 US$) of South Africa in 2014?
Keep it short and to the point. -2.66e+1. What is the difference between the Taxes (in constant 2015 US$) of Armenia in 2010 and the Taxes (in constant 2015 US$) of Belarus in 2011?
Your response must be concise. -6.23e+09. What is the difference between the Taxes (in constant 2015 US$) in Armenia in 2010 and the Taxes (in constant 2015 US$) in Singapore in 2011?
Your answer should be very brief. -1.48e+1. What is the difference between the Taxes (in constant 2015 US$) in Armenia in 2010 and the Taxes (in constant 2015 US$) in South Africa in 2011?
Your answer should be very brief. -4.03e+1. What is the difference between the Taxes (in constant 2015 US$) of Belarus in 2010 and the Taxes (in constant 2015 US$) of Singapore in 2011?
Offer a very short reply. -8.80e+09. What is the difference between the Taxes (in constant 2015 US$) of Belarus in 2010 and the Taxes (in constant 2015 US$) of South Africa in 2011?
Make the answer very short. -3.43e+1. What is the difference between the Taxes (in constant 2015 US$) in Singapore in 2010 and the Taxes (in constant 2015 US$) in South Africa in 2011?
Offer a very short reply. -2.81e+1. What is the difference between the Taxes (in constant 2015 US$) of Armenia in 2010 and the Taxes (in constant 2015 US$) of Belarus in 2012?
Offer a very short reply. -7.03e+09. What is the difference between the Taxes (in constant 2015 US$) of Armenia in 2010 and the Taxes (in constant 2015 US$) of Singapore in 2012?
Your answer should be very brief. -1.58e+1. What is the difference between the Taxes (in constant 2015 US$) in Armenia in 2010 and the Taxes (in constant 2015 US$) in South Africa in 2012?
Provide a succinct answer. -3.83e+1. What is the difference between the Taxes (in constant 2015 US$) of Belarus in 2010 and the Taxes (in constant 2015 US$) of Singapore in 2012?
Give a very brief answer. -9.83e+09. What is the difference between the Taxes (in constant 2015 US$) in Belarus in 2010 and the Taxes (in constant 2015 US$) in South Africa in 2012?
Give a very brief answer. -3.23e+1. What is the difference between the Taxes (in constant 2015 US$) in Singapore in 2010 and the Taxes (in constant 2015 US$) in South Africa in 2012?
Give a very brief answer. -2.62e+1. What is the difference between the Taxes (in constant 2015 US$) in Armenia in 2010 and the Taxes (in constant 2015 US$) in Belarus in 2013?
Offer a terse response. -7.92e+09. What is the difference between the Taxes (in constant 2015 US$) of Armenia in 2010 and the Taxes (in constant 2015 US$) of Singapore in 2013?
Offer a terse response. -1.66e+1. What is the difference between the Taxes (in constant 2015 US$) of Armenia in 2010 and the Taxes (in constant 2015 US$) of South Africa in 2013?
Ensure brevity in your answer.  -3.64e+1. What is the difference between the Taxes (in constant 2015 US$) in Belarus in 2010 and the Taxes (in constant 2015 US$) in Singapore in 2013?
Keep it short and to the point. -1.06e+1. What is the difference between the Taxes (in constant 2015 US$) in Belarus in 2010 and the Taxes (in constant 2015 US$) in South Africa in 2013?
Your response must be concise. -3.04e+1. What is the difference between the Taxes (in constant 2015 US$) of Singapore in 2010 and the Taxes (in constant 2015 US$) of South Africa in 2013?
Your answer should be very brief. -2.43e+1. What is the difference between the Taxes (in constant 2015 US$) in Armenia in 2010 and the Taxes (in constant 2015 US$) in Belarus in 2014?
Offer a very short reply. -8.17e+09. What is the difference between the Taxes (in constant 2015 US$) of Armenia in 2010 and the Taxes (in constant 2015 US$) of Singapore in 2014?
Make the answer very short. -1.60e+1. What is the difference between the Taxes (in constant 2015 US$) in Armenia in 2010 and the Taxes (in constant 2015 US$) in South Africa in 2014?
Your answer should be very brief. -3.51e+1. What is the difference between the Taxes (in constant 2015 US$) in Belarus in 2010 and the Taxes (in constant 2015 US$) in Singapore in 2014?
Your answer should be very brief. -1.00e+1. What is the difference between the Taxes (in constant 2015 US$) in Belarus in 2010 and the Taxes (in constant 2015 US$) in South Africa in 2014?
Keep it short and to the point. -2.91e+1. What is the difference between the Taxes (in constant 2015 US$) of Singapore in 2010 and the Taxes (in constant 2015 US$) of South Africa in 2014?
Offer a terse response. -2.30e+1. What is the difference between the Taxes (in constant 2015 US$) of Armenia in 2011 and the Taxes (in constant 2015 US$) of Belarus in 2012?
Your answer should be very brief. -6.97e+09. What is the difference between the Taxes (in constant 2015 US$) in Armenia in 2011 and the Taxes (in constant 2015 US$) in Singapore in 2012?
Give a very brief answer. -1.57e+1. What is the difference between the Taxes (in constant 2015 US$) in Armenia in 2011 and the Taxes (in constant 2015 US$) in South Africa in 2012?
Your response must be concise. -3.82e+1. What is the difference between the Taxes (in constant 2015 US$) of Belarus in 2011 and the Taxes (in constant 2015 US$) of Singapore in 2012?
Provide a short and direct response. -9.56e+09. What is the difference between the Taxes (in constant 2015 US$) of Belarus in 2011 and the Taxes (in constant 2015 US$) of South Africa in 2012?
Your answer should be very brief. -3.21e+1. What is the difference between the Taxes (in constant 2015 US$) in Singapore in 2011 and the Taxes (in constant 2015 US$) in South Africa in 2012?
Make the answer very short. -2.35e+1. What is the difference between the Taxes (in constant 2015 US$) in Armenia in 2011 and the Taxes (in constant 2015 US$) in Belarus in 2013?
Offer a terse response. -7.85e+09. What is the difference between the Taxes (in constant 2015 US$) in Armenia in 2011 and the Taxes (in constant 2015 US$) in Singapore in 2013?
Your response must be concise. -1.65e+1. What is the difference between the Taxes (in constant 2015 US$) of Armenia in 2011 and the Taxes (in constant 2015 US$) of South Africa in 2013?
Offer a very short reply. -3.63e+1. What is the difference between the Taxes (in constant 2015 US$) of Belarus in 2011 and the Taxes (in constant 2015 US$) of Singapore in 2013?
Provide a succinct answer. -1.04e+1. What is the difference between the Taxes (in constant 2015 US$) of Belarus in 2011 and the Taxes (in constant 2015 US$) of South Africa in 2013?
Make the answer very short. -3.02e+1. What is the difference between the Taxes (in constant 2015 US$) in Singapore in 2011 and the Taxes (in constant 2015 US$) in South Africa in 2013?
Keep it short and to the point. -2.16e+1. What is the difference between the Taxes (in constant 2015 US$) in Armenia in 2011 and the Taxes (in constant 2015 US$) in Belarus in 2014?
Provide a short and direct response. -8.10e+09. What is the difference between the Taxes (in constant 2015 US$) of Armenia in 2011 and the Taxes (in constant 2015 US$) of Singapore in 2014?
Give a very brief answer. -1.59e+1. What is the difference between the Taxes (in constant 2015 US$) in Armenia in 2011 and the Taxes (in constant 2015 US$) in South Africa in 2014?
Provide a succinct answer. -3.50e+1. What is the difference between the Taxes (in constant 2015 US$) of Belarus in 2011 and the Taxes (in constant 2015 US$) of Singapore in 2014?
Your answer should be compact. -9.75e+09. What is the difference between the Taxes (in constant 2015 US$) of Belarus in 2011 and the Taxes (in constant 2015 US$) of South Africa in 2014?
Provide a short and direct response. -2.89e+1. What is the difference between the Taxes (in constant 2015 US$) in Singapore in 2011 and the Taxes (in constant 2015 US$) in South Africa in 2014?
Your answer should be very brief. -2.03e+1. What is the difference between the Taxes (in constant 2015 US$) in Armenia in 2012 and the Taxes (in constant 2015 US$) in Belarus in 2013?
Provide a short and direct response. -7.82e+09. What is the difference between the Taxes (in constant 2015 US$) of Armenia in 2012 and the Taxes (in constant 2015 US$) of Singapore in 2013?
Ensure brevity in your answer.  -1.65e+1. What is the difference between the Taxes (in constant 2015 US$) of Armenia in 2012 and the Taxes (in constant 2015 US$) of South Africa in 2013?
Your answer should be compact. -3.63e+1. What is the difference between the Taxes (in constant 2015 US$) of Belarus in 2012 and the Taxes (in constant 2015 US$) of Singapore in 2013?
Your response must be concise. -9.55e+09. What is the difference between the Taxes (in constant 2015 US$) in Belarus in 2012 and the Taxes (in constant 2015 US$) in South Africa in 2013?
Provide a short and direct response. -2.94e+1. What is the difference between the Taxes (in constant 2015 US$) in Singapore in 2012 and the Taxes (in constant 2015 US$) in South Africa in 2013?
Provide a short and direct response. -2.06e+1. What is the difference between the Taxes (in constant 2015 US$) of Armenia in 2012 and the Taxes (in constant 2015 US$) of Belarus in 2014?
Your answer should be compact. -8.07e+09. What is the difference between the Taxes (in constant 2015 US$) of Armenia in 2012 and the Taxes (in constant 2015 US$) of Singapore in 2014?
Make the answer very short. -1.59e+1. What is the difference between the Taxes (in constant 2015 US$) in Armenia in 2012 and the Taxes (in constant 2015 US$) in South Africa in 2014?
Make the answer very short. -3.50e+1. What is the difference between the Taxes (in constant 2015 US$) of Belarus in 2012 and the Taxes (in constant 2015 US$) of Singapore in 2014?
Make the answer very short. -8.95e+09. What is the difference between the Taxes (in constant 2015 US$) in Belarus in 2012 and the Taxes (in constant 2015 US$) in South Africa in 2014?
Your answer should be very brief. -2.81e+1. What is the difference between the Taxes (in constant 2015 US$) of Singapore in 2012 and the Taxes (in constant 2015 US$) of South Africa in 2014?
Give a very brief answer. -1.93e+1. What is the difference between the Taxes (in constant 2015 US$) of Armenia in 2013 and the Taxes (in constant 2015 US$) of Belarus in 2014?
Your answer should be compact. -7.97e+09. What is the difference between the Taxes (in constant 2015 US$) in Armenia in 2013 and the Taxes (in constant 2015 US$) in Singapore in 2014?
Offer a terse response. -1.58e+1. What is the difference between the Taxes (in constant 2015 US$) in Armenia in 2013 and the Taxes (in constant 2015 US$) in South Africa in 2014?
Your answer should be very brief. -3.49e+1. What is the difference between the Taxes (in constant 2015 US$) of Belarus in 2013 and the Taxes (in constant 2015 US$) of Singapore in 2014?
Your answer should be very brief. -8.06e+09. What is the difference between the Taxes (in constant 2015 US$) in Belarus in 2013 and the Taxes (in constant 2015 US$) in South Africa in 2014?
Keep it short and to the point. -2.72e+1. What is the difference between the Taxes (in constant 2015 US$) of Singapore in 2013 and the Taxes (in constant 2015 US$) of South Africa in 2014?
Your response must be concise. -1.85e+1. What is the average Taxes (in constant 2015 US$) of Armenia per year?
Ensure brevity in your answer.  1.13e+09. What is the average Taxes (in constant 2015 US$) of Belarus per year?
Provide a short and direct response. 7.83e+09. What is the average Taxes (in constant 2015 US$) of Singapore per year?
Make the answer very short. 1.38e+1. What is the average Taxes (in constant 2015 US$) of South Africa per year?
Make the answer very short. 3.45e+1. In the year 2007, what is the difference between the Taxes (in constant 2015 US$) in Armenia and Taxes (in constant 2015 US$) in Belarus?
Ensure brevity in your answer.  -5.50e+09. In the year 2007, what is the difference between the Taxes (in constant 2015 US$) of Armenia and Taxes (in constant 2015 US$) of Singapore?
Ensure brevity in your answer.  -9.37e+09. In the year 2007, what is the difference between the Taxes (in constant 2015 US$) in Armenia and Taxes (in constant 2015 US$) in South Africa?
Offer a very short reply. -3.10e+1. In the year 2007, what is the difference between the Taxes (in constant 2015 US$) of Belarus and Taxes (in constant 2015 US$) of Singapore?
Offer a terse response. -3.88e+09. In the year 2007, what is the difference between the Taxes (in constant 2015 US$) of Belarus and Taxes (in constant 2015 US$) of South Africa?
Provide a succinct answer. -2.55e+1. In the year 2007, what is the difference between the Taxes (in constant 2015 US$) in Singapore and Taxes (in constant 2015 US$) in South Africa?
Ensure brevity in your answer.  -2.16e+1. In the year 2008, what is the difference between the Taxes (in constant 2015 US$) of Armenia and Taxes (in constant 2015 US$) of Belarus?
Provide a succinct answer. -7.50e+09. In the year 2008, what is the difference between the Taxes (in constant 2015 US$) of Armenia and Taxes (in constant 2015 US$) of Singapore?
Ensure brevity in your answer.  -8.73e+09. In the year 2008, what is the difference between the Taxes (in constant 2015 US$) of Armenia and Taxes (in constant 2015 US$) of South Africa?
Your response must be concise. -2.67e+1. In the year 2008, what is the difference between the Taxes (in constant 2015 US$) of Belarus and Taxes (in constant 2015 US$) of Singapore?
Provide a succinct answer. -1.24e+09. In the year 2008, what is the difference between the Taxes (in constant 2015 US$) of Belarus and Taxes (in constant 2015 US$) of South Africa?
Your response must be concise. -1.92e+1. In the year 2008, what is the difference between the Taxes (in constant 2015 US$) in Singapore and Taxes (in constant 2015 US$) in South Africa?
Your answer should be very brief. -1.80e+1. In the year 2009, what is the difference between the Taxes (in constant 2015 US$) of Armenia and Taxes (in constant 2015 US$) of Belarus?
Give a very brief answer. -6.00e+09. In the year 2009, what is the difference between the Taxes (in constant 2015 US$) of Armenia and Taxes (in constant 2015 US$) of Singapore?
Keep it short and to the point. -8.67e+09. In the year 2009, what is the difference between the Taxes (in constant 2015 US$) in Armenia and Taxes (in constant 2015 US$) in South Africa?
Offer a very short reply. -2.63e+1. In the year 2009, what is the difference between the Taxes (in constant 2015 US$) of Belarus and Taxes (in constant 2015 US$) of Singapore?
Keep it short and to the point. -2.67e+09. In the year 2009, what is the difference between the Taxes (in constant 2015 US$) in Belarus and Taxes (in constant 2015 US$) in South Africa?
Keep it short and to the point. -2.03e+1. In the year 2009, what is the difference between the Taxes (in constant 2015 US$) of Singapore and Taxes (in constant 2015 US$) of South Africa?
Ensure brevity in your answer.  -1.76e+1. In the year 2010, what is the difference between the Taxes (in constant 2015 US$) of Armenia and Taxes (in constant 2015 US$) of Belarus?
Ensure brevity in your answer.  -5.97e+09. In the year 2010, what is the difference between the Taxes (in constant 2015 US$) of Armenia and Taxes (in constant 2015 US$) of Singapore?
Offer a terse response. -1.21e+1. In the year 2010, what is the difference between the Taxes (in constant 2015 US$) of Armenia and Taxes (in constant 2015 US$) of South Africa?
Offer a terse response. -3.35e+1. In the year 2010, what is the difference between the Taxes (in constant 2015 US$) in Belarus and Taxes (in constant 2015 US$) in Singapore?
Offer a terse response. -6.16e+09. In the year 2010, what is the difference between the Taxes (in constant 2015 US$) of Belarus and Taxes (in constant 2015 US$) of South Africa?
Ensure brevity in your answer.  -2.76e+1. In the year 2010, what is the difference between the Taxes (in constant 2015 US$) of Singapore and Taxes (in constant 2015 US$) of South Africa?
Ensure brevity in your answer.  -2.14e+1. In the year 2011, what is the difference between the Taxes (in constant 2015 US$) of Armenia and Taxes (in constant 2015 US$) of Belarus?
Make the answer very short. -6.17e+09. In the year 2011, what is the difference between the Taxes (in constant 2015 US$) of Armenia and Taxes (in constant 2015 US$) of Singapore?
Ensure brevity in your answer.  -1.47e+1. In the year 2011, what is the difference between the Taxes (in constant 2015 US$) in Armenia and Taxes (in constant 2015 US$) in South Africa?
Offer a very short reply. -4.02e+1. In the year 2011, what is the difference between the Taxes (in constant 2015 US$) of Belarus and Taxes (in constant 2015 US$) of Singapore?
Your answer should be compact. -8.53e+09. In the year 2011, what is the difference between the Taxes (in constant 2015 US$) in Belarus and Taxes (in constant 2015 US$) in South Africa?
Offer a terse response. -3.40e+1. In the year 2011, what is the difference between the Taxes (in constant 2015 US$) in Singapore and Taxes (in constant 2015 US$) in South Africa?
Your response must be concise. -2.55e+1. In the year 2012, what is the difference between the Taxes (in constant 2015 US$) of Armenia and Taxes (in constant 2015 US$) of Belarus?
Your answer should be very brief. -6.93e+09. In the year 2012, what is the difference between the Taxes (in constant 2015 US$) of Armenia and Taxes (in constant 2015 US$) of Singapore?
Your answer should be compact. -1.57e+1. In the year 2012, what is the difference between the Taxes (in constant 2015 US$) of Armenia and Taxes (in constant 2015 US$) of South Africa?
Your answer should be very brief. -3.82e+1. In the year 2012, what is the difference between the Taxes (in constant 2015 US$) of Belarus and Taxes (in constant 2015 US$) of Singapore?
Give a very brief answer. -8.77e+09. In the year 2012, what is the difference between the Taxes (in constant 2015 US$) in Belarus and Taxes (in constant 2015 US$) in South Africa?
Your answer should be very brief. -3.13e+1. In the year 2012, what is the difference between the Taxes (in constant 2015 US$) in Singapore and Taxes (in constant 2015 US$) in South Africa?
Make the answer very short. -2.25e+1. In the year 2013, what is the difference between the Taxes (in constant 2015 US$) in Armenia and Taxes (in constant 2015 US$) in Belarus?
Provide a succinct answer. -7.73e+09. In the year 2013, what is the difference between the Taxes (in constant 2015 US$) of Armenia and Taxes (in constant 2015 US$) of Singapore?
Your answer should be very brief. -1.64e+1. In the year 2013, what is the difference between the Taxes (in constant 2015 US$) in Armenia and Taxes (in constant 2015 US$) in South Africa?
Offer a very short reply. -3.62e+1. In the year 2013, what is the difference between the Taxes (in constant 2015 US$) of Belarus and Taxes (in constant 2015 US$) of Singapore?
Offer a terse response. -8.67e+09. In the year 2013, what is the difference between the Taxes (in constant 2015 US$) of Belarus and Taxes (in constant 2015 US$) of South Africa?
Offer a terse response. -2.85e+1. In the year 2013, what is the difference between the Taxes (in constant 2015 US$) of Singapore and Taxes (in constant 2015 US$) of South Africa?
Offer a terse response. -1.98e+1. In the year 2014, what is the difference between the Taxes (in constant 2015 US$) of Armenia and Taxes (in constant 2015 US$) of Belarus?
Provide a succinct answer. -7.90e+09. In the year 2014, what is the difference between the Taxes (in constant 2015 US$) of Armenia and Taxes (in constant 2015 US$) of Singapore?
Your answer should be very brief. -1.57e+1. In the year 2014, what is the difference between the Taxes (in constant 2015 US$) in Armenia and Taxes (in constant 2015 US$) in South Africa?
Give a very brief answer. -3.48e+1. In the year 2014, what is the difference between the Taxes (in constant 2015 US$) in Belarus and Taxes (in constant 2015 US$) in Singapore?
Give a very brief answer. -7.81e+09. In the year 2014, what is the difference between the Taxes (in constant 2015 US$) in Belarus and Taxes (in constant 2015 US$) in South Africa?
Offer a terse response. -2.69e+1. In the year 2014, what is the difference between the Taxes (in constant 2015 US$) of Singapore and Taxes (in constant 2015 US$) of South Africa?
Your response must be concise. -1.91e+1. What is the ratio of the Taxes (in constant 2015 US$) in Armenia in 2007 to that in 2008?
Keep it short and to the point. 0.7. What is the ratio of the Taxes (in constant 2015 US$) in Belarus in 2007 to that in 2008?
Give a very brief answer. 0.73. What is the ratio of the Taxes (in constant 2015 US$) of Singapore in 2007 to that in 2008?
Give a very brief answer. 1.02. What is the ratio of the Taxes (in constant 2015 US$) in South Africa in 2007 to that in 2008?
Provide a succinct answer. 1.14. What is the ratio of the Taxes (in constant 2015 US$) of Armenia in 2007 to that in 2009?
Offer a very short reply. 1.01. What is the ratio of the Taxes (in constant 2015 US$) of Belarus in 2007 to that in 2009?
Your response must be concise. 0.93. What is the ratio of the Taxes (in constant 2015 US$) of Singapore in 2007 to that in 2009?
Your response must be concise. 1.07. What is the ratio of the Taxes (in constant 2015 US$) in South Africa in 2007 to that in 2009?
Offer a very short reply. 1.17. What is the ratio of the Taxes (in constant 2015 US$) of Armenia in 2007 to that in 2010?
Provide a short and direct response. 0.89. What is the ratio of the Taxes (in constant 2015 US$) in Belarus in 2007 to that in 2010?
Provide a short and direct response. 0.92. What is the ratio of the Taxes (in constant 2015 US$) in Singapore in 2007 to that in 2010?
Offer a very short reply. 0.78. What is the ratio of the Taxes (in constant 2015 US$) of South Africa in 2007 to that in 2010?
Offer a very short reply. 0.92. What is the ratio of the Taxes (in constant 2015 US$) in Armenia in 2007 to that in 2011?
Keep it short and to the point. 0.83. What is the ratio of the Taxes (in constant 2015 US$) in Belarus in 2007 to that in 2011?
Your response must be concise. 0.88. What is the ratio of the Taxes (in constant 2015 US$) in Singapore in 2007 to that in 2011?
Provide a short and direct response. 0.65. What is the ratio of the Taxes (in constant 2015 US$) of South Africa in 2007 to that in 2011?
Ensure brevity in your answer.  0.77. What is the ratio of the Taxes (in constant 2015 US$) of Armenia in 2007 to that in 2012?
Keep it short and to the point. 0.81. What is the ratio of the Taxes (in constant 2015 US$) of Belarus in 2007 to that in 2012?
Ensure brevity in your answer.  0.79. What is the ratio of the Taxes (in constant 2015 US$) in Singapore in 2007 to that in 2012?
Provide a short and direct response. 0.61. What is the ratio of the Taxes (in constant 2015 US$) of South Africa in 2007 to that in 2012?
Ensure brevity in your answer.  0.81. What is the ratio of the Taxes (in constant 2015 US$) in Armenia in 2007 to that in 2013?
Make the answer very short. 0.75. What is the ratio of the Taxes (in constant 2015 US$) in Belarus in 2007 to that in 2013?
Your response must be concise. 0.72. What is the ratio of the Taxes (in constant 2015 US$) of Singapore in 2007 to that in 2013?
Ensure brevity in your answer.  0.58. What is the ratio of the Taxes (in constant 2015 US$) of South Africa in 2007 to that in 2013?
Your response must be concise. 0.85. What is the ratio of the Taxes (in constant 2015 US$) of Armenia in 2007 to that in 2014?
Make the answer very short. 0.7. What is the ratio of the Taxes (in constant 2015 US$) in Belarus in 2007 to that in 2014?
Ensure brevity in your answer.  0.7. What is the ratio of the Taxes (in constant 2015 US$) of Singapore in 2007 to that in 2014?
Make the answer very short. 0.6. What is the ratio of the Taxes (in constant 2015 US$) in South Africa in 2007 to that in 2014?
Offer a terse response. 0.88. What is the ratio of the Taxes (in constant 2015 US$) of Armenia in 2008 to that in 2009?
Your response must be concise. 1.45. What is the ratio of the Taxes (in constant 2015 US$) of Belarus in 2008 to that in 2009?
Give a very brief answer. 1.28. What is the ratio of the Taxes (in constant 2015 US$) of Singapore in 2008 to that in 2009?
Your answer should be compact. 1.05. What is the ratio of the Taxes (in constant 2015 US$) in South Africa in 2008 to that in 2009?
Offer a terse response. 1.03. What is the ratio of the Taxes (in constant 2015 US$) of Armenia in 2008 to that in 2010?
Offer a very short reply. 1.27. What is the ratio of the Taxes (in constant 2015 US$) of Belarus in 2008 to that in 2010?
Provide a succinct answer. 1.26. What is the ratio of the Taxes (in constant 2015 US$) in Singapore in 2008 to that in 2010?
Provide a short and direct response. 0.76. What is the ratio of the Taxes (in constant 2015 US$) of South Africa in 2008 to that in 2010?
Make the answer very short. 0.81. What is the ratio of the Taxes (in constant 2015 US$) in Armenia in 2008 to that in 2011?
Your answer should be very brief. 1.2. What is the ratio of the Taxes (in constant 2015 US$) in Belarus in 2008 to that in 2011?
Offer a terse response. 1.21. What is the ratio of the Taxes (in constant 2015 US$) of Singapore in 2008 to that in 2011?
Ensure brevity in your answer.  0.64. What is the ratio of the Taxes (in constant 2015 US$) of South Africa in 2008 to that in 2011?
Make the answer very short. 0.68. What is the ratio of the Taxes (in constant 2015 US$) of Armenia in 2008 to that in 2012?
Provide a succinct answer. 1.16. What is the ratio of the Taxes (in constant 2015 US$) of Belarus in 2008 to that in 2012?
Offer a terse response. 1.09. What is the ratio of the Taxes (in constant 2015 US$) in Singapore in 2008 to that in 2012?
Ensure brevity in your answer.  0.6. What is the ratio of the Taxes (in constant 2015 US$) in South Africa in 2008 to that in 2012?
Your answer should be very brief. 0.71. What is the ratio of the Taxes (in constant 2015 US$) in Armenia in 2008 to that in 2013?
Provide a succinct answer. 1.07. What is the ratio of the Taxes (in constant 2015 US$) of Belarus in 2008 to that in 2013?
Give a very brief answer. 0.98. What is the ratio of the Taxes (in constant 2015 US$) of Singapore in 2008 to that in 2013?
Make the answer very short. 0.57. What is the ratio of the Taxes (in constant 2015 US$) in South Africa in 2008 to that in 2013?
Ensure brevity in your answer.  0.75. What is the ratio of the Taxes (in constant 2015 US$) of Armenia in 2008 to that in 2014?
Give a very brief answer. 1.01. What is the ratio of the Taxes (in constant 2015 US$) of Belarus in 2008 to that in 2014?
Make the answer very short. 0.96. What is the ratio of the Taxes (in constant 2015 US$) in Singapore in 2008 to that in 2014?
Your answer should be very brief. 0.59. What is the ratio of the Taxes (in constant 2015 US$) in South Africa in 2008 to that in 2014?
Keep it short and to the point. 0.78. What is the ratio of the Taxes (in constant 2015 US$) of Armenia in 2009 to that in 2010?
Make the answer very short. 0.88. What is the ratio of the Taxes (in constant 2015 US$) of Belarus in 2009 to that in 2010?
Your answer should be very brief. 0.99. What is the ratio of the Taxes (in constant 2015 US$) of Singapore in 2009 to that in 2010?
Keep it short and to the point. 0.73. What is the ratio of the Taxes (in constant 2015 US$) in South Africa in 2009 to that in 2010?
Give a very brief answer. 0.79. What is the ratio of the Taxes (in constant 2015 US$) in Armenia in 2009 to that in 2011?
Your answer should be very brief. 0.83. What is the ratio of the Taxes (in constant 2015 US$) of Belarus in 2009 to that in 2011?
Provide a short and direct response. 0.95. What is the ratio of the Taxes (in constant 2015 US$) in Singapore in 2009 to that in 2011?
Offer a terse response. 0.61. What is the ratio of the Taxes (in constant 2015 US$) in South Africa in 2009 to that in 2011?
Make the answer very short. 0.66. What is the ratio of the Taxes (in constant 2015 US$) in Armenia in 2009 to that in 2012?
Provide a short and direct response. 0.8. What is the ratio of the Taxes (in constant 2015 US$) of Belarus in 2009 to that in 2012?
Your answer should be compact. 0.86. What is the ratio of the Taxes (in constant 2015 US$) in Singapore in 2009 to that in 2012?
Keep it short and to the point. 0.57. What is the ratio of the Taxes (in constant 2015 US$) in South Africa in 2009 to that in 2012?
Your answer should be compact. 0.69. What is the ratio of the Taxes (in constant 2015 US$) of Armenia in 2009 to that in 2013?
Provide a short and direct response. 0.74. What is the ratio of the Taxes (in constant 2015 US$) in Belarus in 2009 to that in 2013?
Ensure brevity in your answer.  0.77. What is the ratio of the Taxes (in constant 2015 US$) in Singapore in 2009 to that in 2013?
Your answer should be compact. 0.54. What is the ratio of the Taxes (in constant 2015 US$) of South Africa in 2009 to that in 2013?
Offer a very short reply. 0.73. What is the ratio of the Taxes (in constant 2015 US$) of Armenia in 2009 to that in 2014?
Your response must be concise. 0.7. What is the ratio of the Taxes (in constant 2015 US$) in Belarus in 2009 to that in 2014?
Provide a succinct answer. 0.75. What is the ratio of the Taxes (in constant 2015 US$) in Singapore in 2009 to that in 2014?
Your response must be concise. 0.56. What is the ratio of the Taxes (in constant 2015 US$) of South Africa in 2009 to that in 2014?
Offer a terse response. 0.75. What is the ratio of the Taxes (in constant 2015 US$) in Armenia in 2010 to that in 2011?
Give a very brief answer. 0.94. What is the ratio of the Taxes (in constant 2015 US$) of Belarus in 2010 to that in 2011?
Give a very brief answer. 0.96. What is the ratio of the Taxes (in constant 2015 US$) in Singapore in 2010 to that in 2011?
Provide a succinct answer. 0.83. What is the ratio of the Taxes (in constant 2015 US$) of South Africa in 2010 to that in 2011?
Make the answer very short. 0.84. What is the ratio of the Taxes (in constant 2015 US$) in Armenia in 2010 to that in 2012?
Your response must be concise. 0.91. What is the ratio of the Taxes (in constant 2015 US$) in Belarus in 2010 to that in 2012?
Provide a short and direct response. 0.87. What is the ratio of the Taxes (in constant 2015 US$) of Singapore in 2010 to that in 2012?
Provide a short and direct response. 0.78. What is the ratio of the Taxes (in constant 2015 US$) of South Africa in 2010 to that in 2012?
Offer a terse response. 0.88. What is the ratio of the Taxes (in constant 2015 US$) of Armenia in 2010 to that in 2013?
Make the answer very short. 0.84. What is the ratio of the Taxes (in constant 2015 US$) in Belarus in 2010 to that in 2013?
Provide a short and direct response. 0.78. What is the ratio of the Taxes (in constant 2015 US$) of Singapore in 2010 to that in 2013?
Your answer should be compact. 0.75. What is the ratio of the Taxes (in constant 2015 US$) of South Africa in 2010 to that in 2013?
Offer a terse response. 0.92. What is the ratio of the Taxes (in constant 2015 US$) of Armenia in 2010 to that in 2014?
Your response must be concise. 0.79. What is the ratio of the Taxes (in constant 2015 US$) in Belarus in 2010 to that in 2014?
Provide a succinct answer. 0.76. What is the ratio of the Taxes (in constant 2015 US$) of Singapore in 2010 to that in 2014?
Provide a succinct answer. 0.77. What is the ratio of the Taxes (in constant 2015 US$) of South Africa in 2010 to that in 2014?
Your response must be concise. 0.96. What is the ratio of the Taxes (in constant 2015 US$) in Armenia in 2011 to that in 2012?
Offer a very short reply. 0.97. What is the ratio of the Taxes (in constant 2015 US$) of Belarus in 2011 to that in 2012?
Provide a short and direct response. 0.9. What is the ratio of the Taxes (in constant 2015 US$) of Singapore in 2011 to that in 2012?
Your answer should be very brief. 0.94. What is the ratio of the Taxes (in constant 2015 US$) in South Africa in 2011 to that in 2012?
Your response must be concise. 1.05. What is the ratio of the Taxes (in constant 2015 US$) of Armenia in 2011 to that in 2013?
Give a very brief answer. 0.9. What is the ratio of the Taxes (in constant 2015 US$) of Belarus in 2011 to that in 2013?
Provide a succinct answer. 0.81. What is the ratio of the Taxes (in constant 2015 US$) of Singapore in 2011 to that in 2013?
Your answer should be very brief. 0.9. What is the ratio of the Taxes (in constant 2015 US$) in South Africa in 2011 to that in 2013?
Make the answer very short. 1.1. What is the ratio of the Taxes (in constant 2015 US$) in Armenia in 2011 to that in 2014?
Make the answer very short. 0.84. What is the ratio of the Taxes (in constant 2015 US$) in Belarus in 2011 to that in 2014?
Your response must be concise. 0.79. What is the ratio of the Taxes (in constant 2015 US$) of Singapore in 2011 to that in 2014?
Provide a short and direct response. 0.93. What is the ratio of the Taxes (in constant 2015 US$) in South Africa in 2011 to that in 2014?
Your answer should be compact. 1.14. What is the ratio of the Taxes (in constant 2015 US$) of Armenia in 2012 to that in 2013?
Make the answer very short. 0.92. What is the ratio of the Taxes (in constant 2015 US$) in Belarus in 2012 to that in 2013?
Provide a short and direct response. 0.9. What is the ratio of the Taxes (in constant 2015 US$) in Singapore in 2012 to that in 2013?
Provide a short and direct response. 0.96. What is the ratio of the Taxes (in constant 2015 US$) of South Africa in 2012 to that in 2013?
Provide a succinct answer. 1.05. What is the ratio of the Taxes (in constant 2015 US$) in Armenia in 2012 to that in 2014?
Offer a terse response. 0.87. What is the ratio of the Taxes (in constant 2015 US$) in Belarus in 2012 to that in 2014?
Give a very brief answer. 0.88. What is the ratio of the Taxes (in constant 2015 US$) of Singapore in 2012 to that in 2014?
Your answer should be compact. 0.99. What is the ratio of the Taxes (in constant 2015 US$) of South Africa in 2012 to that in 2014?
Your answer should be compact. 1.09. What is the ratio of the Taxes (in constant 2015 US$) in Armenia in 2013 to that in 2014?
Your answer should be compact. 0.94. What is the ratio of the Taxes (in constant 2015 US$) of Belarus in 2013 to that in 2014?
Keep it short and to the point. 0.97. What is the ratio of the Taxes (in constant 2015 US$) in Singapore in 2013 to that in 2014?
Keep it short and to the point. 1.04. What is the ratio of the Taxes (in constant 2015 US$) in South Africa in 2013 to that in 2014?
Your answer should be very brief. 1.04. What is the difference between the highest and the second highest Taxes (in constant 2015 US$) of Armenia?
Offer a terse response. 1.13e+07. What is the difference between the highest and the second highest Taxes (in constant 2015 US$) of Belarus?
Your answer should be very brief. 2.47e+08. What is the difference between the highest and the second highest Taxes (in constant 2015 US$) of Singapore?
Make the answer very short. 6.07e+08. What is the difference between the highest and the second highest Taxes (in constant 2015 US$) in South Africa?
Your answer should be compact. 1.98e+09. What is the difference between the highest and the lowest Taxes (in constant 2015 US$) of Armenia?
Offer a terse response. 4.09e+08. What is the difference between the highest and the lowest Taxes (in constant 2015 US$) of Belarus?
Provide a succinct answer. 2.79e+09. What is the difference between the highest and the lowest Taxes (in constant 2015 US$) in Singapore?
Provide a short and direct response. 8.04e+09. What is the difference between the highest and the lowest Taxes (in constant 2015 US$) in South Africa?
Your answer should be very brief. 1.41e+1. 